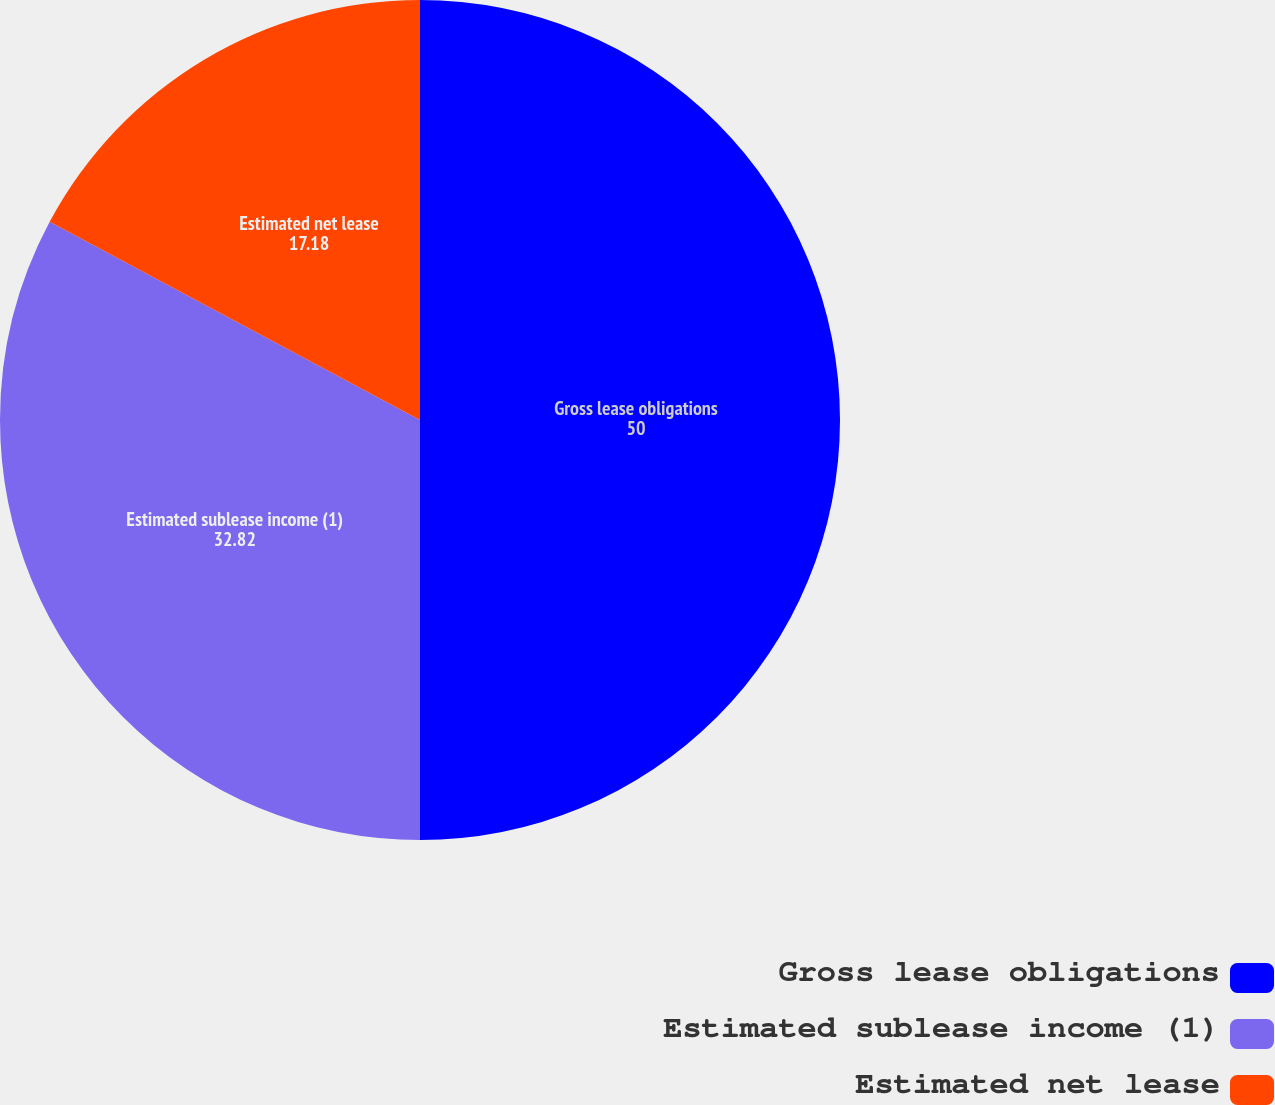Convert chart to OTSL. <chart><loc_0><loc_0><loc_500><loc_500><pie_chart><fcel>Gross lease obligations<fcel>Estimated sublease income (1)<fcel>Estimated net lease<nl><fcel>50.0%<fcel>32.82%<fcel>17.18%<nl></chart> 